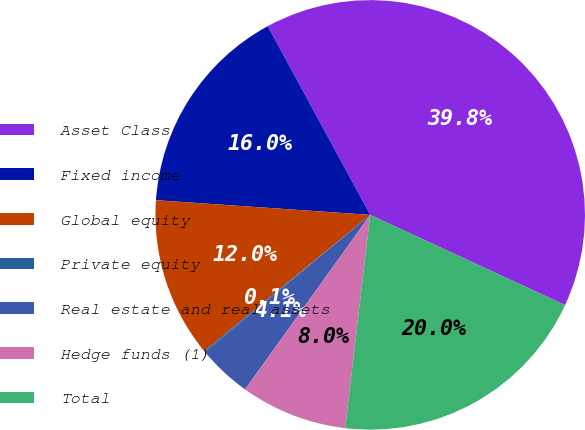<chart> <loc_0><loc_0><loc_500><loc_500><pie_chart><fcel>Asset Class<fcel>Fixed income<fcel>Global equity<fcel>Private equity<fcel>Real estate and real assets<fcel>Hedge funds (1)<fcel>Total<nl><fcel>39.82%<fcel>15.99%<fcel>12.02%<fcel>0.1%<fcel>4.07%<fcel>8.04%<fcel>19.96%<nl></chart> 